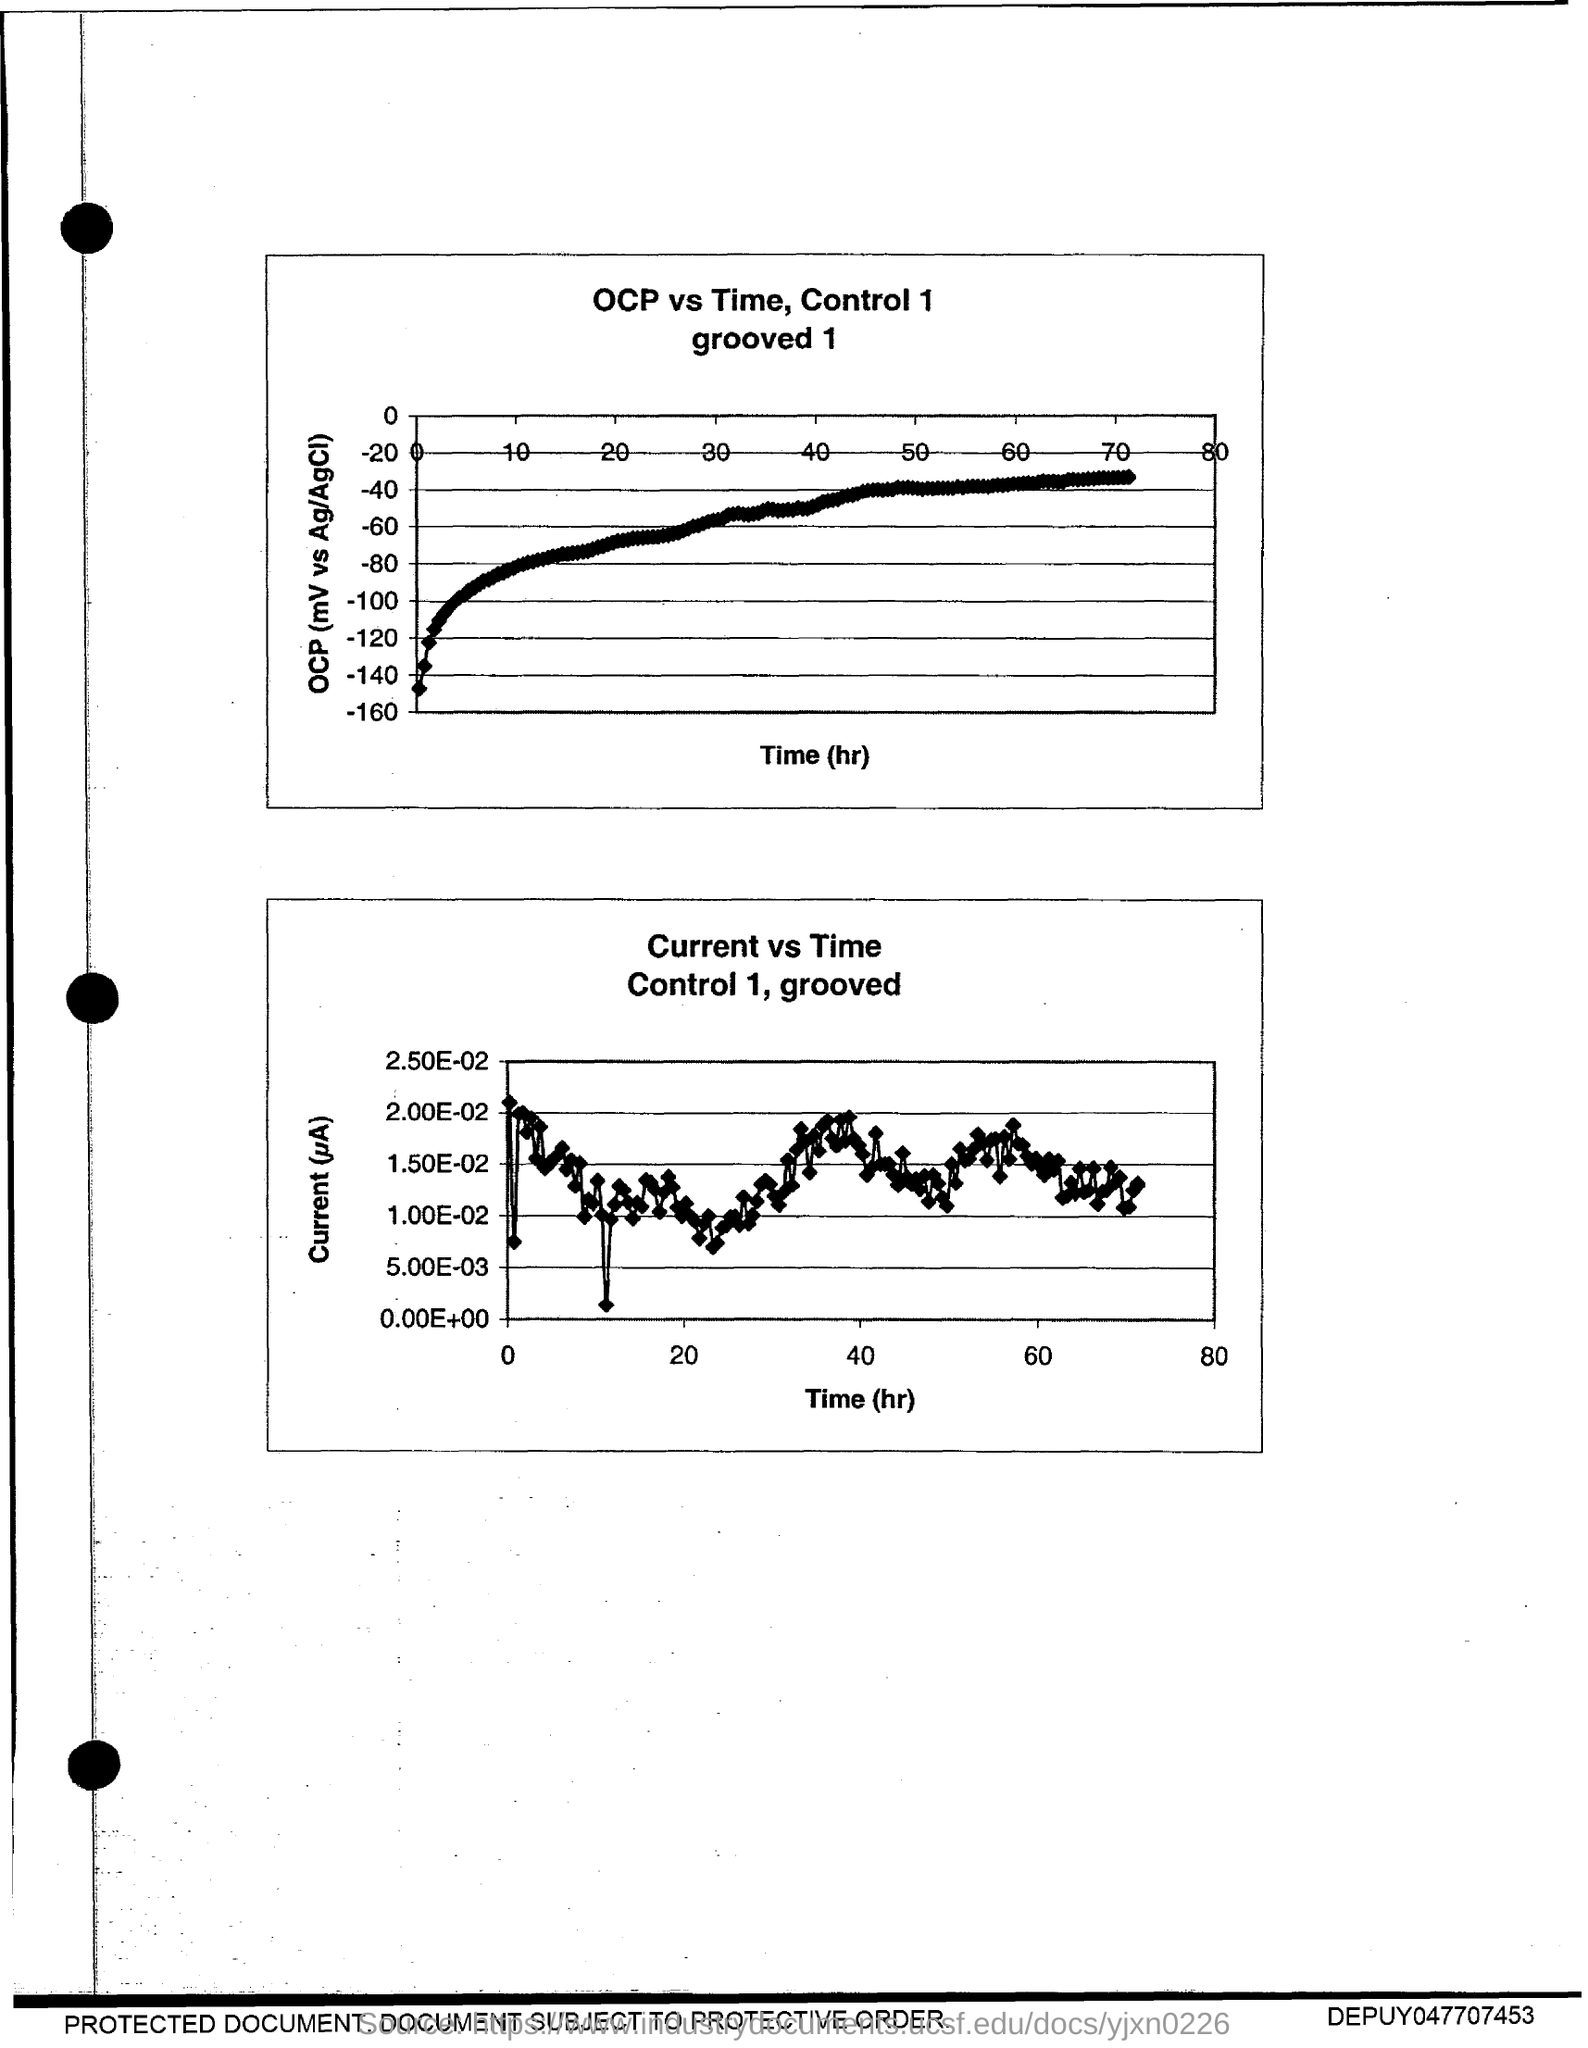List a handful of essential elements in this visual. The title of the first graph is "OCP vs Time, Control 1 grooved 1.." which is a comparison of Optimal Control Point (OCP) values versus time, with a control point of 1 grooved 1. 